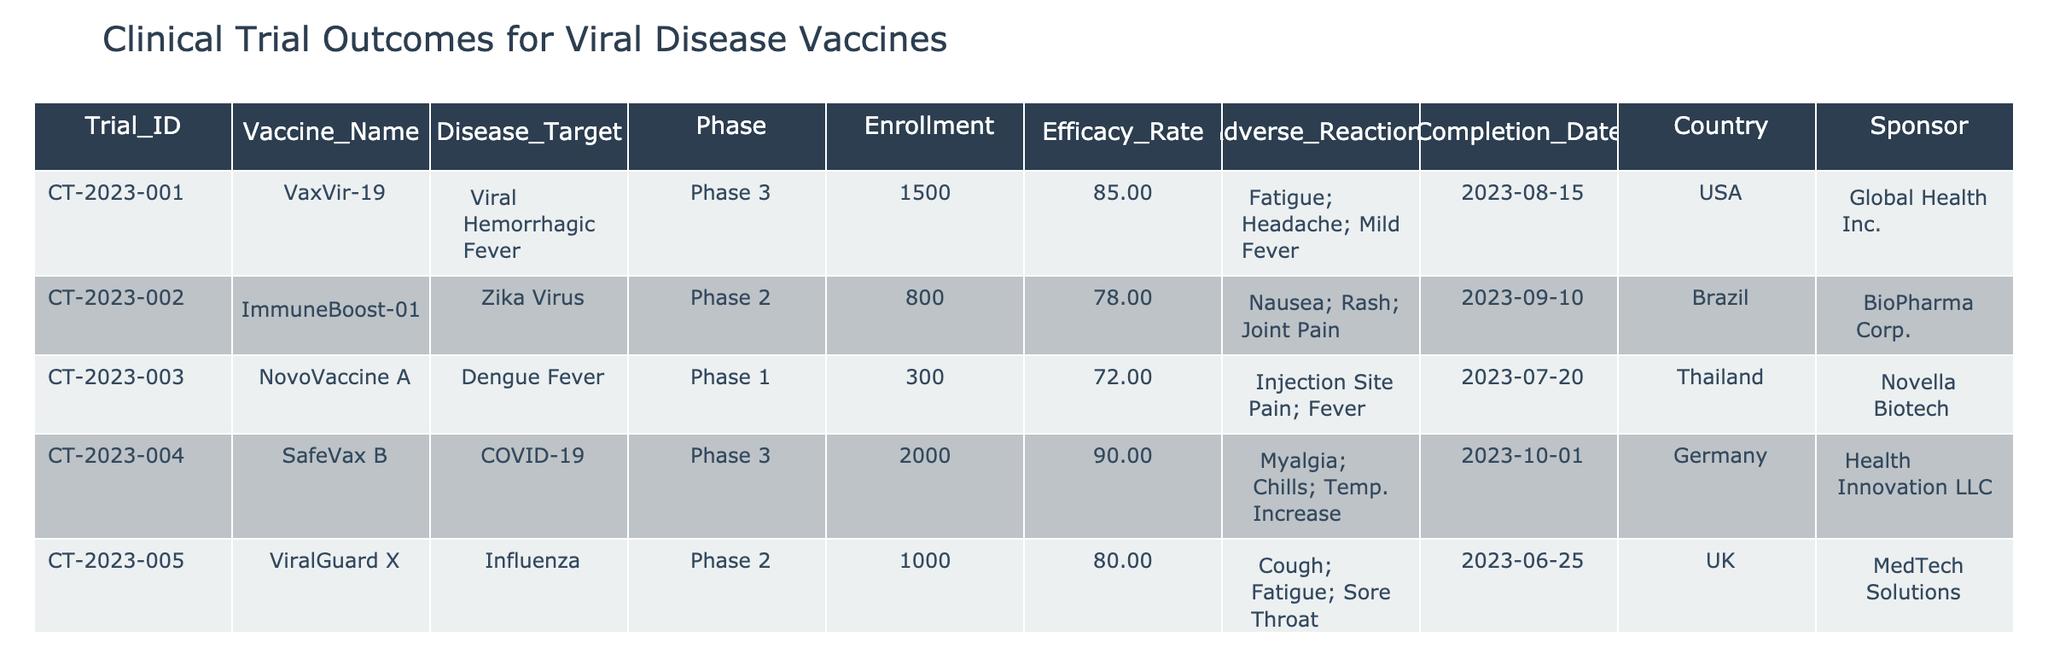What is the vaccine name for the clinical trial targeting Dengue Fever? The table lists the vaccine names along with their corresponding disease targets. In the row for Dengue Fever, the Vaccine_Name is "NovoVaccine A."
Answer: NovoVaccine A How many participants were enrolled in the Phase 3 trial for the COVID-19 vaccine? The enrollment number for the COVID-19 vaccine trial can be found in the corresponding row. The Phase 3 trial for COVID-19 has an Enrollment of 2000 participants.
Answer: 2000 Which vaccine has the highest efficacy rate, and what is that rate? To find the highest efficacy rate, we need to compare the efficacy rates of all vaccines listed. "ProtectVax" has the highest efficacy rate of 95.
Answer: ProtectVax; 95 How many total adverse reactions are reported for vaccines in Phase 2 trials? We identify the vaccines in Phase 2 and count the number of unique adverse reactions. "ImmuneBoost-01" has 3 reactions and "ViralGuard X" also has 3 reactions. Therefore, the total number is 3 + 3 = 6 unique adverse reactions reported.
Answer: 6 Is the trial for "VaxVir-19" completed? The Completion_Date for "VaxVir-19" is noted as 2023-08-15, which means it has been completed as of that date.
Answer: Yes Which country is sponsoring the trial with the highest enrollment? The table shows the maximum Enrollment (2000 participants) which corresponds to the trial sponsored by "Health Innovation LLC" in Germany for the COVID-19 vaccine.
Answer: Germany What is the average efficacy rate of vaccines in Phase 3 trials? We take the efficacy rates for the Phase 3 trials: 85 (VaxVir-19), 90 (SafeVax B), and 95 (ProtectVax). The sum is 85 + 90 + 95 = 270, and there are 3 trials, so the average is 270 / 3 = 90.
Answer: 90 Is there any vaccine targeting the "Zika Virus" that reports joint pain as an adverse reaction? By checking the adverse reactions listed for the "ImmuneBoost-01" (the vaccine targeting Zika Virus) we see that it does report joint pain among its adverse reactions.
Answer: Yes 